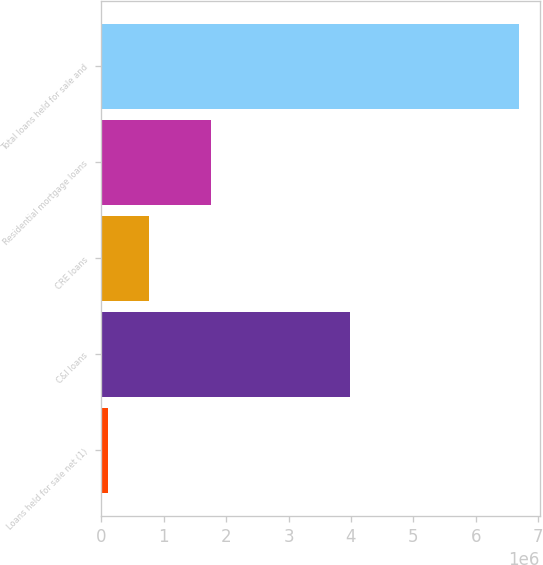Convert chart to OTSL. <chart><loc_0><loc_0><loc_500><loc_500><bar_chart><fcel>Loans held for sale net (1)<fcel>C&I loans<fcel>CRE loans<fcel>Residential mortgage loans<fcel>Total loans held for sale and<nl><fcel>102236<fcel>3.98712e+06<fcel>761378<fcel>1.75492e+06<fcel>6.69366e+06<nl></chart> 